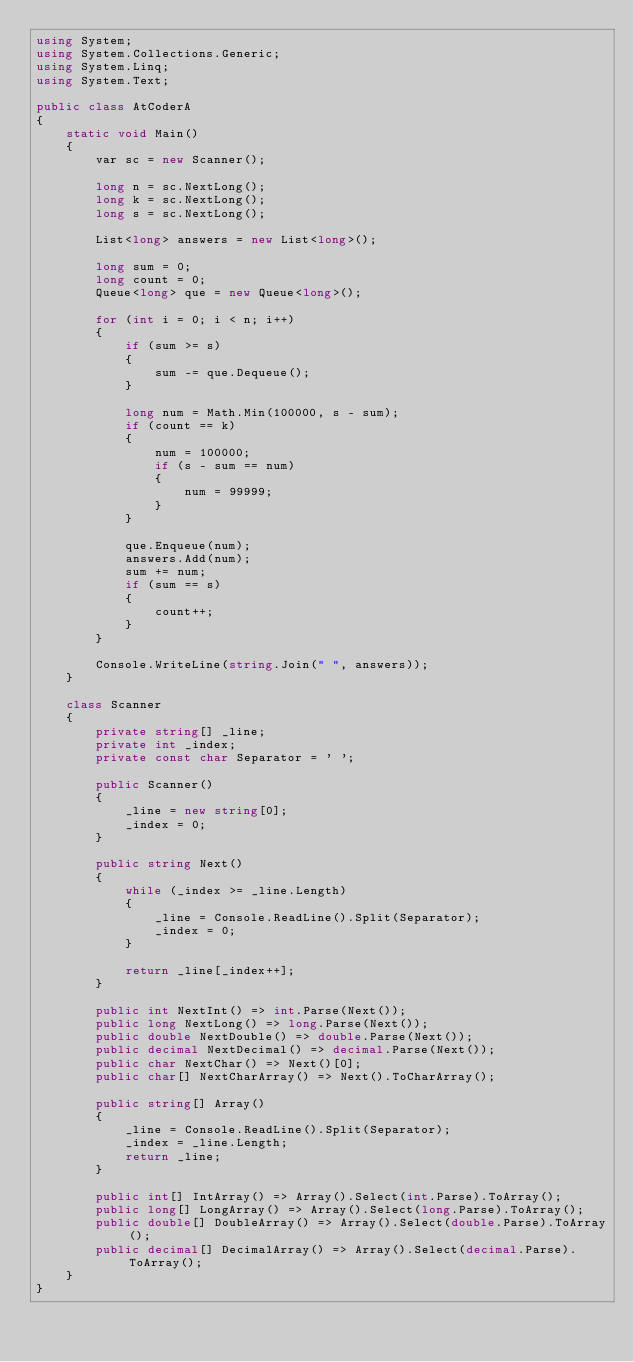Convert code to text. <code><loc_0><loc_0><loc_500><loc_500><_C#_>using System;
using System.Collections.Generic;
using System.Linq;
using System.Text;

public class AtCoderA
{
    static void Main()
    {
        var sc = new Scanner();

        long n = sc.NextLong();
        long k = sc.NextLong();
        long s = sc.NextLong();

        List<long> answers = new List<long>();

        long sum = 0;
        long count = 0;
        Queue<long> que = new Queue<long>();

        for (int i = 0; i < n; i++)
        {
            if (sum >= s)
            {
                sum -= que.Dequeue();
            }

            long num = Math.Min(100000, s - sum);
            if (count == k)
            {
                num = 100000;
                if (s - sum == num)
                {
                    num = 99999;
                }
            }

            que.Enqueue(num);
            answers.Add(num);
            sum += num;
            if (sum == s)
            {
                count++;
            }
        }

        Console.WriteLine(string.Join(" ", answers));
    }

    class Scanner
    {
        private string[] _line;
        private int _index;
        private const char Separator = ' ';

        public Scanner()
        {
            _line = new string[0];
            _index = 0;
        }

        public string Next()
        {
            while (_index >= _line.Length)
            {
                _line = Console.ReadLine().Split(Separator);
                _index = 0;
            }

            return _line[_index++];
        }

        public int NextInt() => int.Parse(Next());
        public long NextLong() => long.Parse(Next());
        public double NextDouble() => double.Parse(Next());
        public decimal NextDecimal() => decimal.Parse(Next());
        public char NextChar() => Next()[0];
        public char[] NextCharArray() => Next().ToCharArray();

        public string[] Array()
        {
            _line = Console.ReadLine().Split(Separator);
            _index = _line.Length;
            return _line;
        }

        public int[] IntArray() => Array().Select(int.Parse).ToArray();
        public long[] LongArray() => Array().Select(long.Parse).ToArray();
        public double[] DoubleArray() => Array().Select(double.Parse).ToArray();
        public decimal[] DecimalArray() => Array().Select(decimal.Parse).ToArray();
    }
}
</code> 